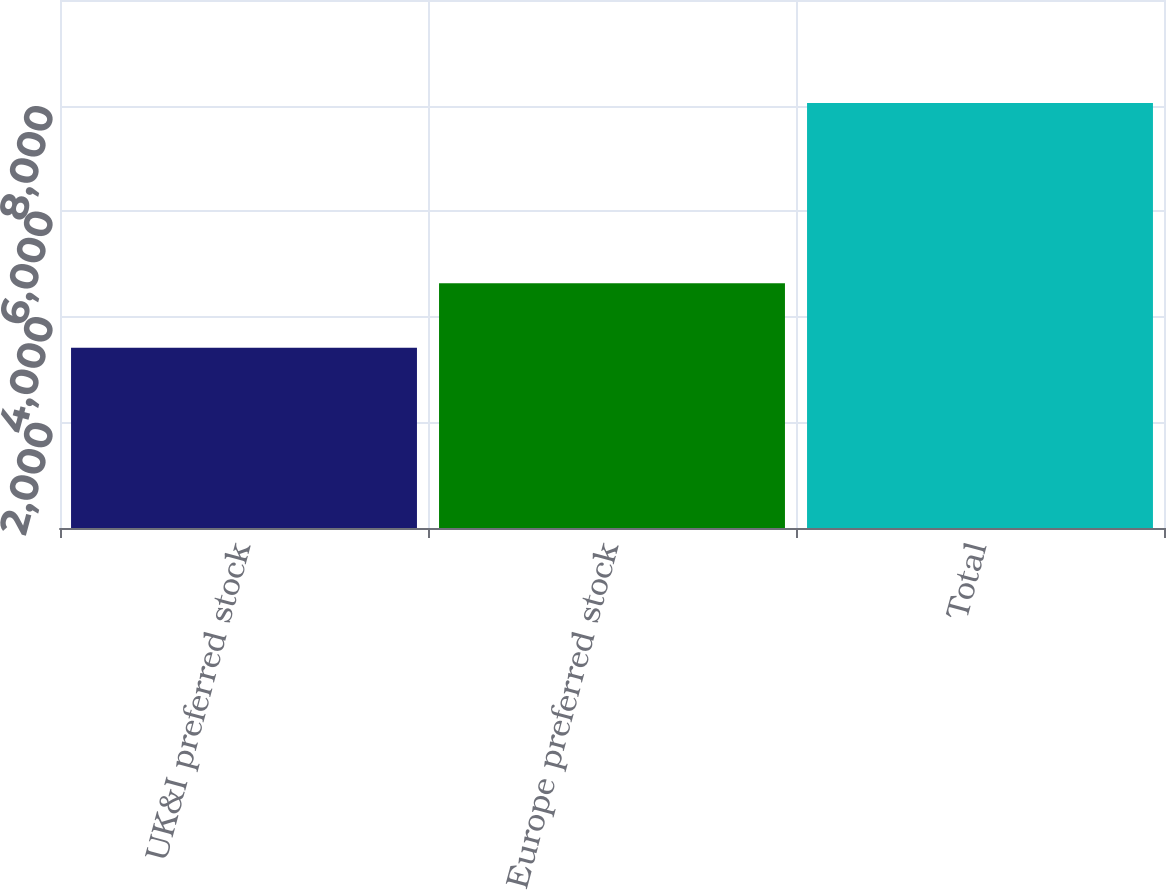Convert chart. <chart><loc_0><loc_0><loc_500><loc_500><bar_chart><fcel>UK&I preferred stock<fcel>Europe preferred stock<fcel>Total<nl><fcel>3414<fcel>4634<fcel>8048<nl></chart> 